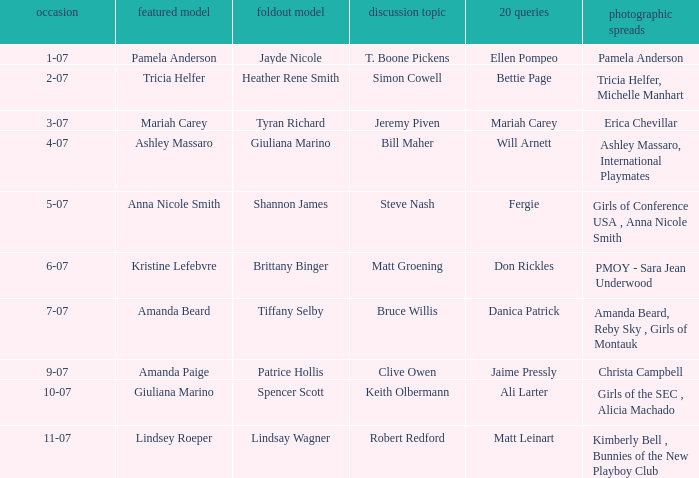Could you parse the entire table? {'header': ['occasion', 'featured model', 'foldout model', 'discussion topic', '20 queries', 'photographic spreads'], 'rows': [['1-07', 'Pamela Anderson', 'Jayde Nicole', 'T. Boone Pickens', 'Ellen Pompeo', 'Pamela Anderson'], ['2-07', 'Tricia Helfer', 'Heather Rene Smith', 'Simon Cowell', 'Bettie Page', 'Tricia Helfer, Michelle Manhart'], ['3-07', 'Mariah Carey', 'Tyran Richard', 'Jeremy Piven', 'Mariah Carey', 'Erica Chevillar'], ['4-07', 'Ashley Massaro', 'Giuliana Marino', 'Bill Maher', 'Will Arnett', 'Ashley Massaro, International Playmates'], ['5-07', 'Anna Nicole Smith', 'Shannon James', 'Steve Nash', 'Fergie', 'Girls of Conference USA , Anna Nicole Smith'], ['6-07', 'Kristine Lefebvre', 'Brittany Binger', 'Matt Groening', 'Don Rickles', 'PMOY - Sara Jean Underwood'], ['7-07', 'Amanda Beard', 'Tiffany Selby', 'Bruce Willis', 'Danica Patrick', 'Amanda Beard, Reby Sky , Girls of Montauk'], ['9-07', 'Amanda Paige', 'Patrice Hollis', 'Clive Owen', 'Jaime Pressly', 'Christa Campbell'], ['10-07', 'Giuliana Marino', 'Spencer Scott', 'Keith Olbermann', 'Ali Larter', 'Girls of the SEC , Alicia Machado'], ['11-07', 'Lindsey Roeper', 'Lindsay Wagner', 'Robert Redford', 'Matt Leinart', 'Kimberly Bell , Bunnies of the New Playboy Club']]} Who answered the 20 questions on 10-07? Ali Larter. 